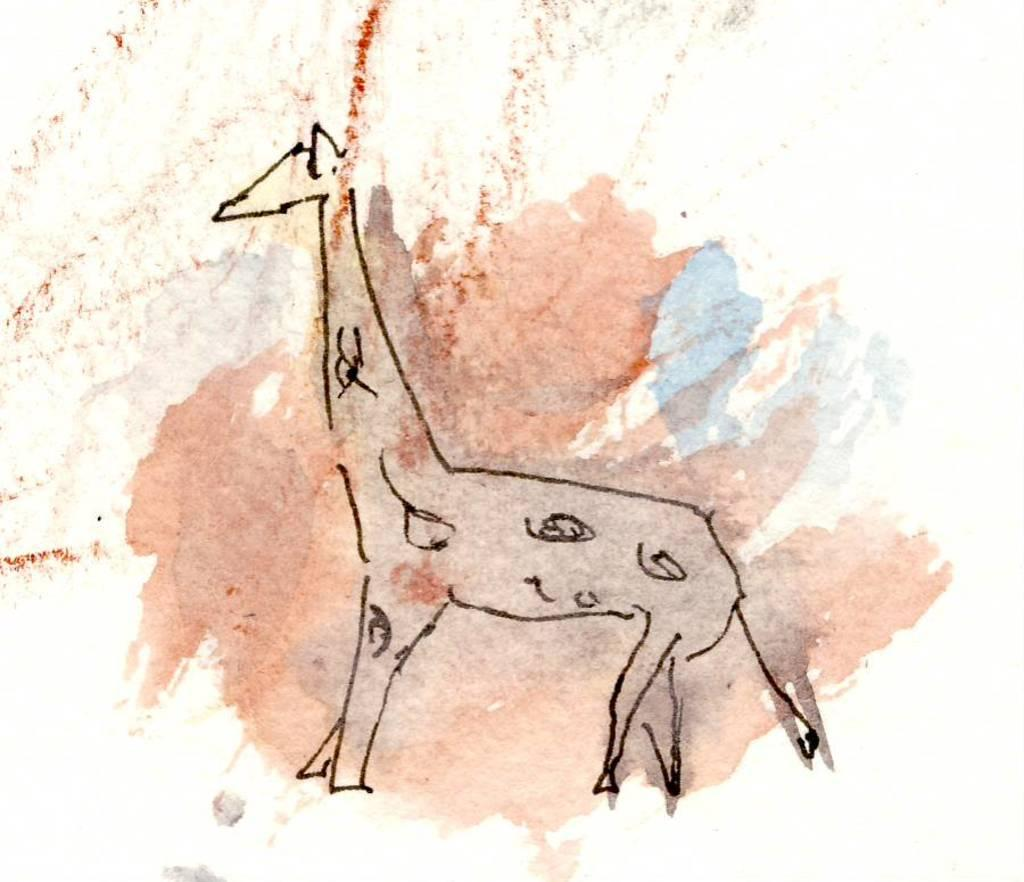What is depicted in the image? There is a drawing of a giraffe in the image. What type of flowers can be seen in the image? There are no flowers present in the image; it features a drawing of a giraffe. Who is the manager of the giraffe in the image? The image is a drawing of a giraffe, and animals do not have managers. 